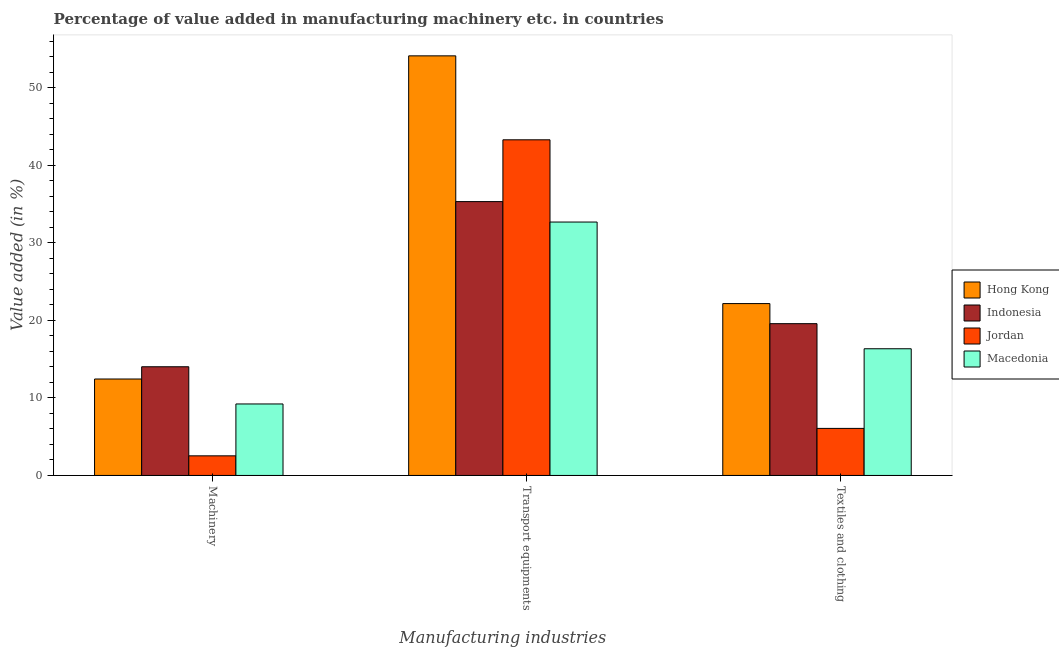How many different coloured bars are there?
Keep it short and to the point. 4. How many groups of bars are there?
Offer a terse response. 3. Are the number of bars per tick equal to the number of legend labels?
Keep it short and to the point. Yes. Are the number of bars on each tick of the X-axis equal?
Make the answer very short. Yes. How many bars are there on the 1st tick from the left?
Provide a short and direct response. 4. How many bars are there on the 3rd tick from the right?
Your answer should be very brief. 4. What is the label of the 1st group of bars from the left?
Give a very brief answer. Machinery. What is the value added in manufacturing textile and clothing in Indonesia?
Your answer should be compact. 19.58. Across all countries, what is the maximum value added in manufacturing machinery?
Make the answer very short. 14.02. Across all countries, what is the minimum value added in manufacturing transport equipments?
Your response must be concise. 32.69. In which country was the value added in manufacturing transport equipments maximum?
Make the answer very short. Hong Kong. In which country was the value added in manufacturing machinery minimum?
Offer a terse response. Jordan. What is the total value added in manufacturing textile and clothing in the graph?
Your answer should be compact. 64.16. What is the difference between the value added in manufacturing textile and clothing in Macedonia and that in Indonesia?
Your answer should be compact. -3.24. What is the difference between the value added in manufacturing transport equipments in Indonesia and the value added in manufacturing machinery in Hong Kong?
Your answer should be compact. 22.88. What is the average value added in manufacturing textile and clothing per country?
Give a very brief answer. 16.04. What is the difference between the value added in manufacturing machinery and value added in manufacturing textile and clothing in Indonesia?
Provide a short and direct response. -5.56. What is the ratio of the value added in manufacturing textile and clothing in Macedonia to that in Hong Kong?
Your answer should be compact. 0.74. Is the value added in manufacturing transport equipments in Jordan less than that in Macedonia?
Your answer should be compact. No. What is the difference between the highest and the second highest value added in manufacturing textile and clothing?
Offer a terse response. 2.59. What is the difference between the highest and the lowest value added in manufacturing transport equipments?
Provide a short and direct response. 21.44. What does the 2nd bar from the right in Textiles and clothing represents?
Give a very brief answer. Jordan. How many bars are there?
Offer a terse response. 12. Are all the bars in the graph horizontal?
Offer a terse response. No. Does the graph contain any zero values?
Your answer should be compact. No. Does the graph contain grids?
Provide a succinct answer. No. Where does the legend appear in the graph?
Give a very brief answer. Center right. How are the legend labels stacked?
Make the answer very short. Vertical. What is the title of the graph?
Keep it short and to the point. Percentage of value added in manufacturing machinery etc. in countries. Does "Virgin Islands" appear as one of the legend labels in the graph?
Ensure brevity in your answer.  No. What is the label or title of the X-axis?
Keep it short and to the point. Manufacturing industries. What is the label or title of the Y-axis?
Your answer should be very brief. Value added (in %). What is the Value added (in %) of Hong Kong in Machinery?
Keep it short and to the point. 12.44. What is the Value added (in %) in Indonesia in Machinery?
Make the answer very short. 14.02. What is the Value added (in %) of Jordan in Machinery?
Ensure brevity in your answer.  2.53. What is the Value added (in %) of Macedonia in Machinery?
Offer a terse response. 9.22. What is the Value added (in %) of Hong Kong in Transport equipments?
Your response must be concise. 54.12. What is the Value added (in %) in Indonesia in Transport equipments?
Your answer should be compact. 35.32. What is the Value added (in %) in Jordan in Transport equipments?
Give a very brief answer. 43.29. What is the Value added (in %) of Macedonia in Transport equipments?
Your answer should be very brief. 32.69. What is the Value added (in %) in Hong Kong in Textiles and clothing?
Your response must be concise. 22.17. What is the Value added (in %) of Indonesia in Textiles and clothing?
Ensure brevity in your answer.  19.58. What is the Value added (in %) in Jordan in Textiles and clothing?
Offer a terse response. 6.07. What is the Value added (in %) in Macedonia in Textiles and clothing?
Offer a very short reply. 16.34. Across all Manufacturing industries, what is the maximum Value added (in %) of Hong Kong?
Your answer should be compact. 54.12. Across all Manufacturing industries, what is the maximum Value added (in %) in Indonesia?
Your response must be concise. 35.32. Across all Manufacturing industries, what is the maximum Value added (in %) of Jordan?
Ensure brevity in your answer.  43.29. Across all Manufacturing industries, what is the maximum Value added (in %) in Macedonia?
Your answer should be compact. 32.69. Across all Manufacturing industries, what is the minimum Value added (in %) in Hong Kong?
Provide a succinct answer. 12.44. Across all Manufacturing industries, what is the minimum Value added (in %) of Indonesia?
Give a very brief answer. 14.02. Across all Manufacturing industries, what is the minimum Value added (in %) in Jordan?
Make the answer very short. 2.53. Across all Manufacturing industries, what is the minimum Value added (in %) in Macedonia?
Keep it short and to the point. 9.22. What is the total Value added (in %) in Hong Kong in the graph?
Offer a very short reply. 88.73. What is the total Value added (in %) of Indonesia in the graph?
Ensure brevity in your answer.  68.92. What is the total Value added (in %) in Jordan in the graph?
Provide a succinct answer. 51.89. What is the total Value added (in %) in Macedonia in the graph?
Give a very brief answer. 58.25. What is the difference between the Value added (in %) of Hong Kong in Machinery and that in Transport equipments?
Ensure brevity in your answer.  -41.68. What is the difference between the Value added (in %) in Indonesia in Machinery and that in Transport equipments?
Provide a succinct answer. -21.3. What is the difference between the Value added (in %) of Jordan in Machinery and that in Transport equipments?
Provide a succinct answer. -40.77. What is the difference between the Value added (in %) of Macedonia in Machinery and that in Transport equipments?
Make the answer very short. -23.47. What is the difference between the Value added (in %) of Hong Kong in Machinery and that in Textiles and clothing?
Provide a succinct answer. -9.73. What is the difference between the Value added (in %) in Indonesia in Machinery and that in Textiles and clothing?
Your answer should be very brief. -5.56. What is the difference between the Value added (in %) in Jordan in Machinery and that in Textiles and clothing?
Offer a very short reply. -3.54. What is the difference between the Value added (in %) of Macedonia in Machinery and that in Textiles and clothing?
Provide a short and direct response. -7.12. What is the difference between the Value added (in %) in Hong Kong in Transport equipments and that in Textiles and clothing?
Your answer should be very brief. 31.96. What is the difference between the Value added (in %) in Indonesia in Transport equipments and that in Textiles and clothing?
Keep it short and to the point. 15.74. What is the difference between the Value added (in %) in Jordan in Transport equipments and that in Textiles and clothing?
Give a very brief answer. 37.22. What is the difference between the Value added (in %) of Macedonia in Transport equipments and that in Textiles and clothing?
Keep it short and to the point. 16.34. What is the difference between the Value added (in %) in Hong Kong in Machinery and the Value added (in %) in Indonesia in Transport equipments?
Provide a succinct answer. -22.88. What is the difference between the Value added (in %) in Hong Kong in Machinery and the Value added (in %) in Jordan in Transport equipments?
Make the answer very short. -30.85. What is the difference between the Value added (in %) of Hong Kong in Machinery and the Value added (in %) of Macedonia in Transport equipments?
Make the answer very short. -20.25. What is the difference between the Value added (in %) of Indonesia in Machinery and the Value added (in %) of Jordan in Transport equipments?
Make the answer very short. -29.27. What is the difference between the Value added (in %) of Indonesia in Machinery and the Value added (in %) of Macedonia in Transport equipments?
Provide a short and direct response. -18.67. What is the difference between the Value added (in %) in Jordan in Machinery and the Value added (in %) in Macedonia in Transport equipments?
Ensure brevity in your answer.  -30.16. What is the difference between the Value added (in %) in Hong Kong in Machinery and the Value added (in %) in Indonesia in Textiles and clothing?
Provide a succinct answer. -7.14. What is the difference between the Value added (in %) of Hong Kong in Machinery and the Value added (in %) of Jordan in Textiles and clothing?
Make the answer very short. 6.37. What is the difference between the Value added (in %) of Hong Kong in Machinery and the Value added (in %) of Macedonia in Textiles and clothing?
Offer a very short reply. -3.9. What is the difference between the Value added (in %) of Indonesia in Machinery and the Value added (in %) of Jordan in Textiles and clothing?
Provide a succinct answer. 7.95. What is the difference between the Value added (in %) of Indonesia in Machinery and the Value added (in %) of Macedonia in Textiles and clothing?
Keep it short and to the point. -2.32. What is the difference between the Value added (in %) in Jordan in Machinery and the Value added (in %) in Macedonia in Textiles and clothing?
Give a very brief answer. -13.81. What is the difference between the Value added (in %) of Hong Kong in Transport equipments and the Value added (in %) of Indonesia in Textiles and clothing?
Your response must be concise. 34.54. What is the difference between the Value added (in %) in Hong Kong in Transport equipments and the Value added (in %) in Jordan in Textiles and clothing?
Your answer should be compact. 48.05. What is the difference between the Value added (in %) in Hong Kong in Transport equipments and the Value added (in %) in Macedonia in Textiles and clothing?
Your response must be concise. 37.78. What is the difference between the Value added (in %) in Indonesia in Transport equipments and the Value added (in %) in Jordan in Textiles and clothing?
Provide a short and direct response. 29.25. What is the difference between the Value added (in %) of Indonesia in Transport equipments and the Value added (in %) of Macedonia in Textiles and clothing?
Make the answer very short. 18.98. What is the difference between the Value added (in %) of Jordan in Transport equipments and the Value added (in %) of Macedonia in Textiles and clothing?
Offer a very short reply. 26.95. What is the average Value added (in %) of Hong Kong per Manufacturing industries?
Give a very brief answer. 29.58. What is the average Value added (in %) of Indonesia per Manufacturing industries?
Your response must be concise. 22.97. What is the average Value added (in %) of Jordan per Manufacturing industries?
Provide a succinct answer. 17.3. What is the average Value added (in %) in Macedonia per Manufacturing industries?
Provide a succinct answer. 19.42. What is the difference between the Value added (in %) of Hong Kong and Value added (in %) of Indonesia in Machinery?
Your answer should be compact. -1.58. What is the difference between the Value added (in %) of Hong Kong and Value added (in %) of Jordan in Machinery?
Your answer should be very brief. 9.91. What is the difference between the Value added (in %) in Hong Kong and Value added (in %) in Macedonia in Machinery?
Your answer should be very brief. 3.22. What is the difference between the Value added (in %) of Indonesia and Value added (in %) of Jordan in Machinery?
Provide a short and direct response. 11.49. What is the difference between the Value added (in %) of Indonesia and Value added (in %) of Macedonia in Machinery?
Offer a terse response. 4.8. What is the difference between the Value added (in %) of Jordan and Value added (in %) of Macedonia in Machinery?
Your answer should be compact. -6.69. What is the difference between the Value added (in %) in Hong Kong and Value added (in %) in Indonesia in Transport equipments?
Ensure brevity in your answer.  18.8. What is the difference between the Value added (in %) of Hong Kong and Value added (in %) of Jordan in Transport equipments?
Your response must be concise. 10.83. What is the difference between the Value added (in %) of Hong Kong and Value added (in %) of Macedonia in Transport equipments?
Offer a very short reply. 21.44. What is the difference between the Value added (in %) of Indonesia and Value added (in %) of Jordan in Transport equipments?
Offer a very short reply. -7.97. What is the difference between the Value added (in %) in Indonesia and Value added (in %) in Macedonia in Transport equipments?
Offer a terse response. 2.64. What is the difference between the Value added (in %) of Jordan and Value added (in %) of Macedonia in Transport equipments?
Keep it short and to the point. 10.61. What is the difference between the Value added (in %) in Hong Kong and Value added (in %) in Indonesia in Textiles and clothing?
Provide a short and direct response. 2.59. What is the difference between the Value added (in %) in Hong Kong and Value added (in %) in Jordan in Textiles and clothing?
Offer a terse response. 16.1. What is the difference between the Value added (in %) in Hong Kong and Value added (in %) in Macedonia in Textiles and clothing?
Provide a succinct answer. 5.83. What is the difference between the Value added (in %) of Indonesia and Value added (in %) of Jordan in Textiles and clothing?
Provide a short and direct response. 13.51. What is the difference between the Value added (in %) of Indonesia and Value added (in %) of Macedonia in Textiles and clothing?
Provide a succinct answer. 3.24. What is the difference between the Value added (in %) of Jordan and Value added (in %) of Macedonia in Textiles and clothing?
Your response must be concise. -10.27. What is the ratio of the Value added (in %) in Hong Kong in Machinery to that in Transport equipments?
Make the answer very short. 0.23. What is the ratio of the Value added (in %) in Indonesia in Machinery to that in Transport equipments?
Make the answer very short. 0.4. What is the ratio of the Value added (in %) in Jordan in Machinery to that in Transport equipments?
Your response must be concise. 0.06. What is the ratio of the Value added (in %) in Macedonia in Machinery to that in Transport equipments?
Keep it short and to the point. 0.28. What is the ratio of the Value added (in %) of Hong Kong in Machinery to that in Textiles and clothing?
Your answer should be very brief. 0.56. What is the ratio of the Value added (in %) of Indonesia in Machinery to that in Textiles and clothing?
Make the answer very short. 0.72. What is the ratio of the Value added (in %) of Jordan in Machinery to that in Textiles and clothing?
Make the answer very short. 0.42. What is the ratio of the Value added (in %) in Macedonia in Machinery to that in Textiles and clothing?
Provide a succinct answer. 0.56. What is the ratio of the Value added (in %) in Hong Kong in Transport equipments to that in Textiles and clothing?
Ensure brevity in your answer.  2.44. What is the ratio of the Value added (in %) of Indonesia in Transport equipments to that in Textiles and clothing?
Offer a terse response. 1.8. What is the ratio of the Value added (in %) of Jordan in Transport equipments to that in Textiles and clothing?
Make the answer very short. 7.13. What is the ratio of the Value added (in %) in Macedonia in Transport equipments to that in Textiles and clothing?
Your answer should be very brief. 2. What is the difference between the highest and the second highest Value added (in %) in Hong Kong?
Keep it short and to the point. 31.96. What is the difference between the highest and the second highest Value added (in %) in Indonesia?
Offer a terse response. 15.74. What is the difference between the highest and the second highest Value added (in %) of Jordan?
Give a very brief answer. 37.22. What is the difference between the highest and the second highest Value added (in %) in Macedonia?
Your answer should be very brief. 16.34. What is the difference between the highest and the lowest Value added (in %) of Hong Kong?
Your response must be concise. 41.68. What is the difference between the highest and the lowest Value added (in %) of Indonesia?
Provide a succinct answer. 21.3. What is the difference between the highest and the lowest Value added (in %) of Jordan?
Offer a very short reply. 40.77. What is the difference between the highest and the lowest Value added (in %) in Macedonia?
Provide a succinct answer. 23.47. 